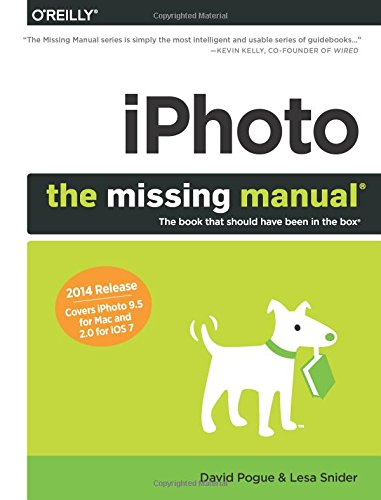What type of book is this? This book falls under the category of Computers & Technology, focusing specifically on teaching the uses and functionalities of the iPhoto software systems for both Mac and iOS platforms. 